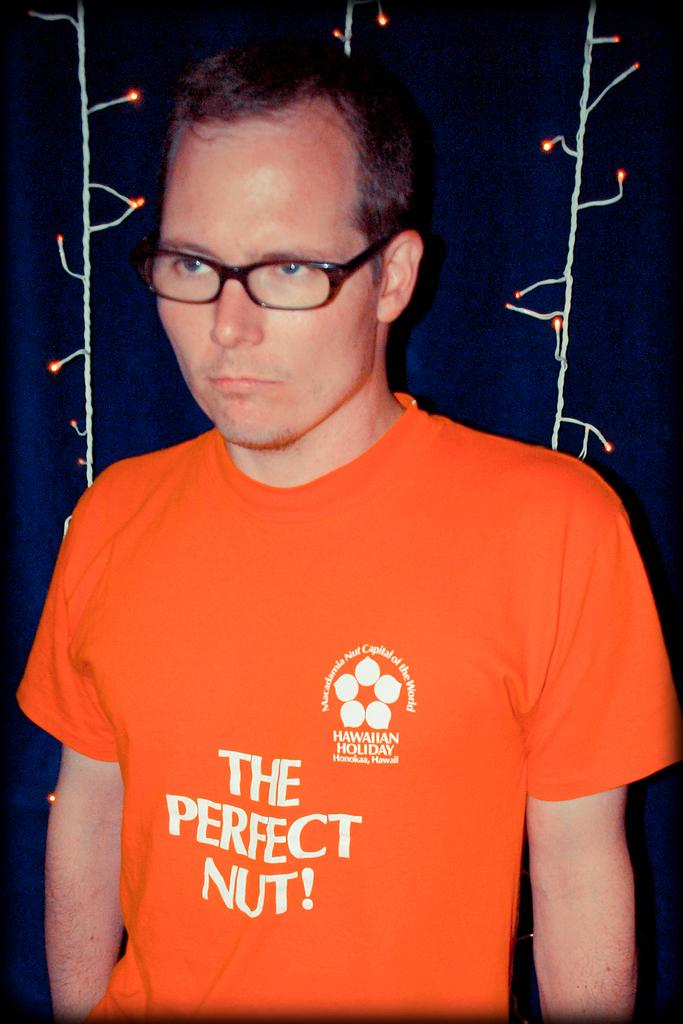What is the main subject of the image? There is a person in the image. Can you describe the person's appearance? The person is wearing glasses. What can be seen in the background of the image? There are decorative lights behind the person. How many pizzas are being shared between the person and their loved one in the image? There is no mention of pizzas or a loved one in the image; it only features a person wearing glasses and decorative lights in the background. 